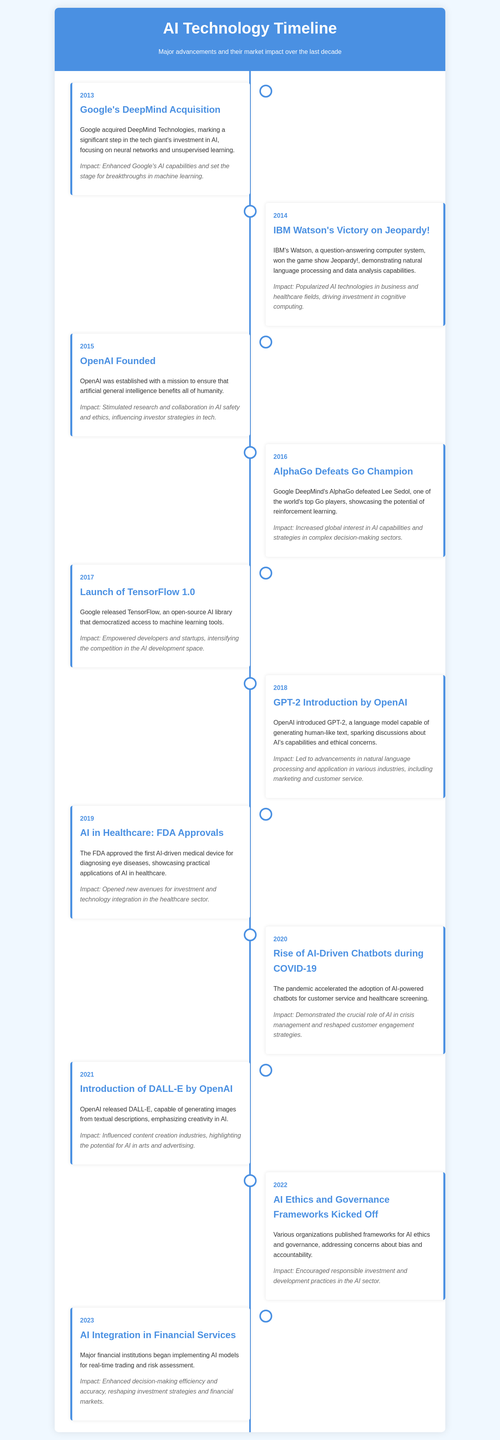What significant event happened in 2013? The document mentions that Google acquired DeepMind Technologies in 2013.
Answer: Google acquired DeepMind Technologies What was the year of IBM Watson's victory on Jeopardy!? According to the timeline, IBM Watson won Jeopardy! in 2014.
Answer: 2014 Which AI model was introduced by OpenAI in 2018? The document states that OpenAI introduced GPT-2 in 2018.
Answer: GPT-2 What was the impact of TensorFlow's launch in 2017? TensorFlow's launch empowered developers and startups, intensifying competition in the AI development space as stated in the document.
Answer: Empowered developers and startups In which year did AlphaGo defeat a Go champion? The timeline indicates that AlphaGo defeated the Go champion in 2016.
Answer: 2016 What does AI integration in financial services in 2023 signify? AI integration in financial services signifies enhanced decision-making efficiency and accuracy.
Answer: Enhanced decision-making efficiency and accuracy What advancement was made in healthcare in 2019? The document reports that the FDA approved the first AI-driven medical device for diagnosing eye diseases in 2019.
Answer: First AI-driven medical device What was a key focus of OpenAI when it was founded in 2015? The document highlights that OpenAI was established with a mission to ensure that artificial general intelligence benefits all of humanity.
Answer: Benefits all of humanity What ethical concerns were addressed in 2022? The timeline states that various organizations published frameworks for AI ethics and governance, addressing bias and accountability.
Answer: Bias and accountability 